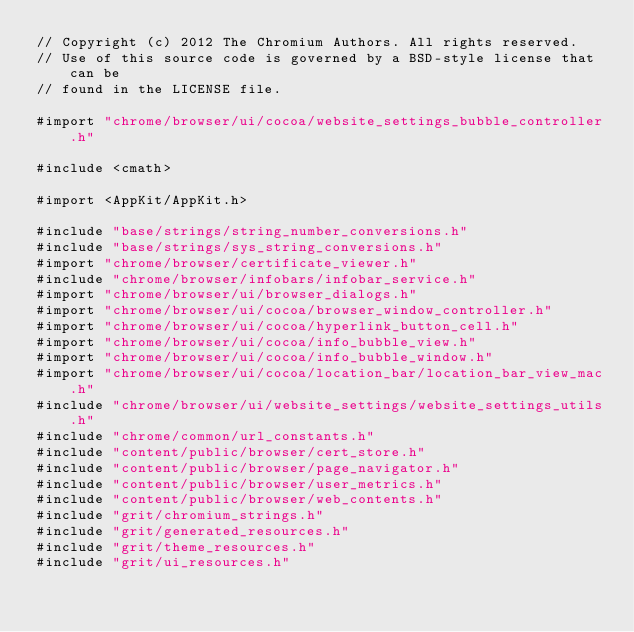<code> <loc_0><loc_0><loc_500><loc_500><_ObjectiveC_>// Copyright (c) 2012 The Chromium Authors. All rights reserved.
// Use of this source code is governed by a BSD-style license that can be
// found in the LICENSE file.

#import "chrome/browser/ui/cocoa/website_settings_bubble_controller.h"

#include <cmath>

#import <AppKit/AppKit.h>

#include "base/strings/string_number_conversions.h"
#include "base/strings/sys_string_conversions.h"
#import "chrome/browser/certificate_viewer.h"
#include "chrome/browser/infobars/infobar_service.h"
#import "chrome/browser/ui/browser_dialogs.h"
#import "chrome/browser/ui/cocoa/browser_window_controller.h"
#import "chrome/browser/ui/cocoa/hyperlink_button_cell.h"
#import "chrome/browser/ui/cocoa/info_bubble_view.h"
#import "chrome/browser/ui/cocoa/info_bubble_window.h"
#import "chrome/browser/ui/cocoa/location_bar/location_bar_view_mac.h"
#include "chrome/browser/ui/website_settings/website_settings_utils.h"
#include "chrome/common/url_constants.h"
#include "content/public/browser/cert_store.h"
#include "content/public/browser/page_navigator.h"
#include "content/public/browser/user_metrics.h"
#include "content/public/browser/web_contents.h"
#include "grit/chromium_strings.h"
#include "grit/generated_resources.h"
#include "grit/theme_resources.h"
#include "grit/ui_resources.h"</code> 